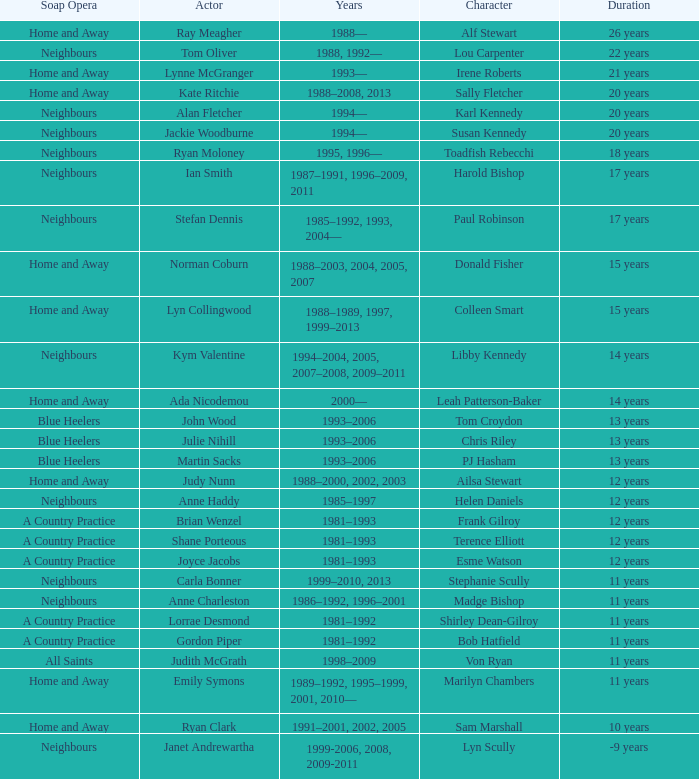Parse the table in full. {'header': ['Soap Opera', 'Actor', 'Years', 'Character', 'Duration'], 'rows': [['Home and Away', 'Ray Meagher', '1988—', 'Alf Stewart', '26 years'], ['Neighbours', 'Tom Oliver', '1988, 1992—', 'Lou Carpenter', '22 years'], ['Home and Away', 'Lynne McGranger', '1993—', 'Irene Roberts', '21 years'], ['Home and Away', 'Kate Ritchie', '1988–2008, 2013', 'Sally Fletcher', '20 years'], ['Neighbours', 'Alan Fletcher', '1994—', 'Karl Kennedy', '20 years'], ['Neighbours', 'Jackie Woodburne', '1994—', 'Susan Kennedy', '20 years'], ['Neighbours', 'Ryan Moloney', '1995, 1996—', 'Toadfish Rebecchi', '18 years'], ['Neighbours', 'Ian Smith', '1987–1991, 1996–2009, 2011', 'Harold Bishop', '17 years'], ['Neighbours', 'Stefan Dennis', '1985–1992, 1993, 2004—', 'Paul Robinson', '17 years'], ['Home and Away', 'Norman Coburn', '1988–2003, 2004, 2005, 2007', 'Donald Fisher', '15 years'], ['Home and Away', 'Lyn Collingwood', '1988–1989, 1997, 1999–2013', 'Colleen Smart', '15 years'], ['Neighbours', 'Kym Valentine', '1994–2004, 2005, 2007–2008, 2009–2011', 'Libby Kennedy', '14 years'], ['Home and Away', 'Ada Nicodemou', '2000—', 'Leah Patterson-Baker', '14 years'], ['Blue Heelers', 'John Wood', '1993–2006', 'Tom Croydon', '13 years'], ['Blue Heelers', 'Julie Nihill', '1993–2006', 'Chris Riley', '13 years'], ['Blue Heelers', 'Martin Sacks', '1993–2006', 'PJ Hasham', '13 years'], ['Home and Away', 'Judy Nunn', '1988–2000, 2002, 2003', 'Ailsa Stewart', '12 years'], ['Neighbours', 'Anne Haddy', '1985–1997', 'Helen Daniels', '12 years'], ['A Country Practice', 'Brian Wenzel', '1981–1993', 'Frank Gilroy', '12 years'], ['A Country Practice', 'Shane Porteous', '1981–1993', 'Terence Elliott', '12 years'], ['A Country Practice', 'Joyce Jacobs', '1981–1993', 'Esme Watson', '12 years'], ['Neighbours', 'Carla Bonner', '1999–2010, 2013', 'Stephanie Scully', '11 years'], ['Neighbours', 'Anne Charleston', '1986–1992, 1996–2001', 'Madge Bishop', '11 years'], ['A Country Practice', 'Lorrae Desmond', '1981–1992', 'Shirley Dean-Gilroy', '11 years'], ['A Country Practice', 'Gordon Piper', '1981–1992', 'Bob Hatfield', '11 years'], ['All Saints', 'Judith McGrath', '1998–2009', 'Von Ryan', '11 years'], ['Home and Away', 'Emily Symons', '1989–1992, 1995–1999, 2001, 2010—', 'Marilyn Chambers', '11 years'], ['Home and Away', 'Ryan Clark', '1991–2001, 2002, 2005', 'Sam Marshall', '10 years'], ['Neighbours', 'Janet Andrewartha', '1999-2006, 2008, 2009-2011', 'Lyn Scully', '-9 years']]} Which years did Martin Sacks work on a soap opera? 1993–2006. 